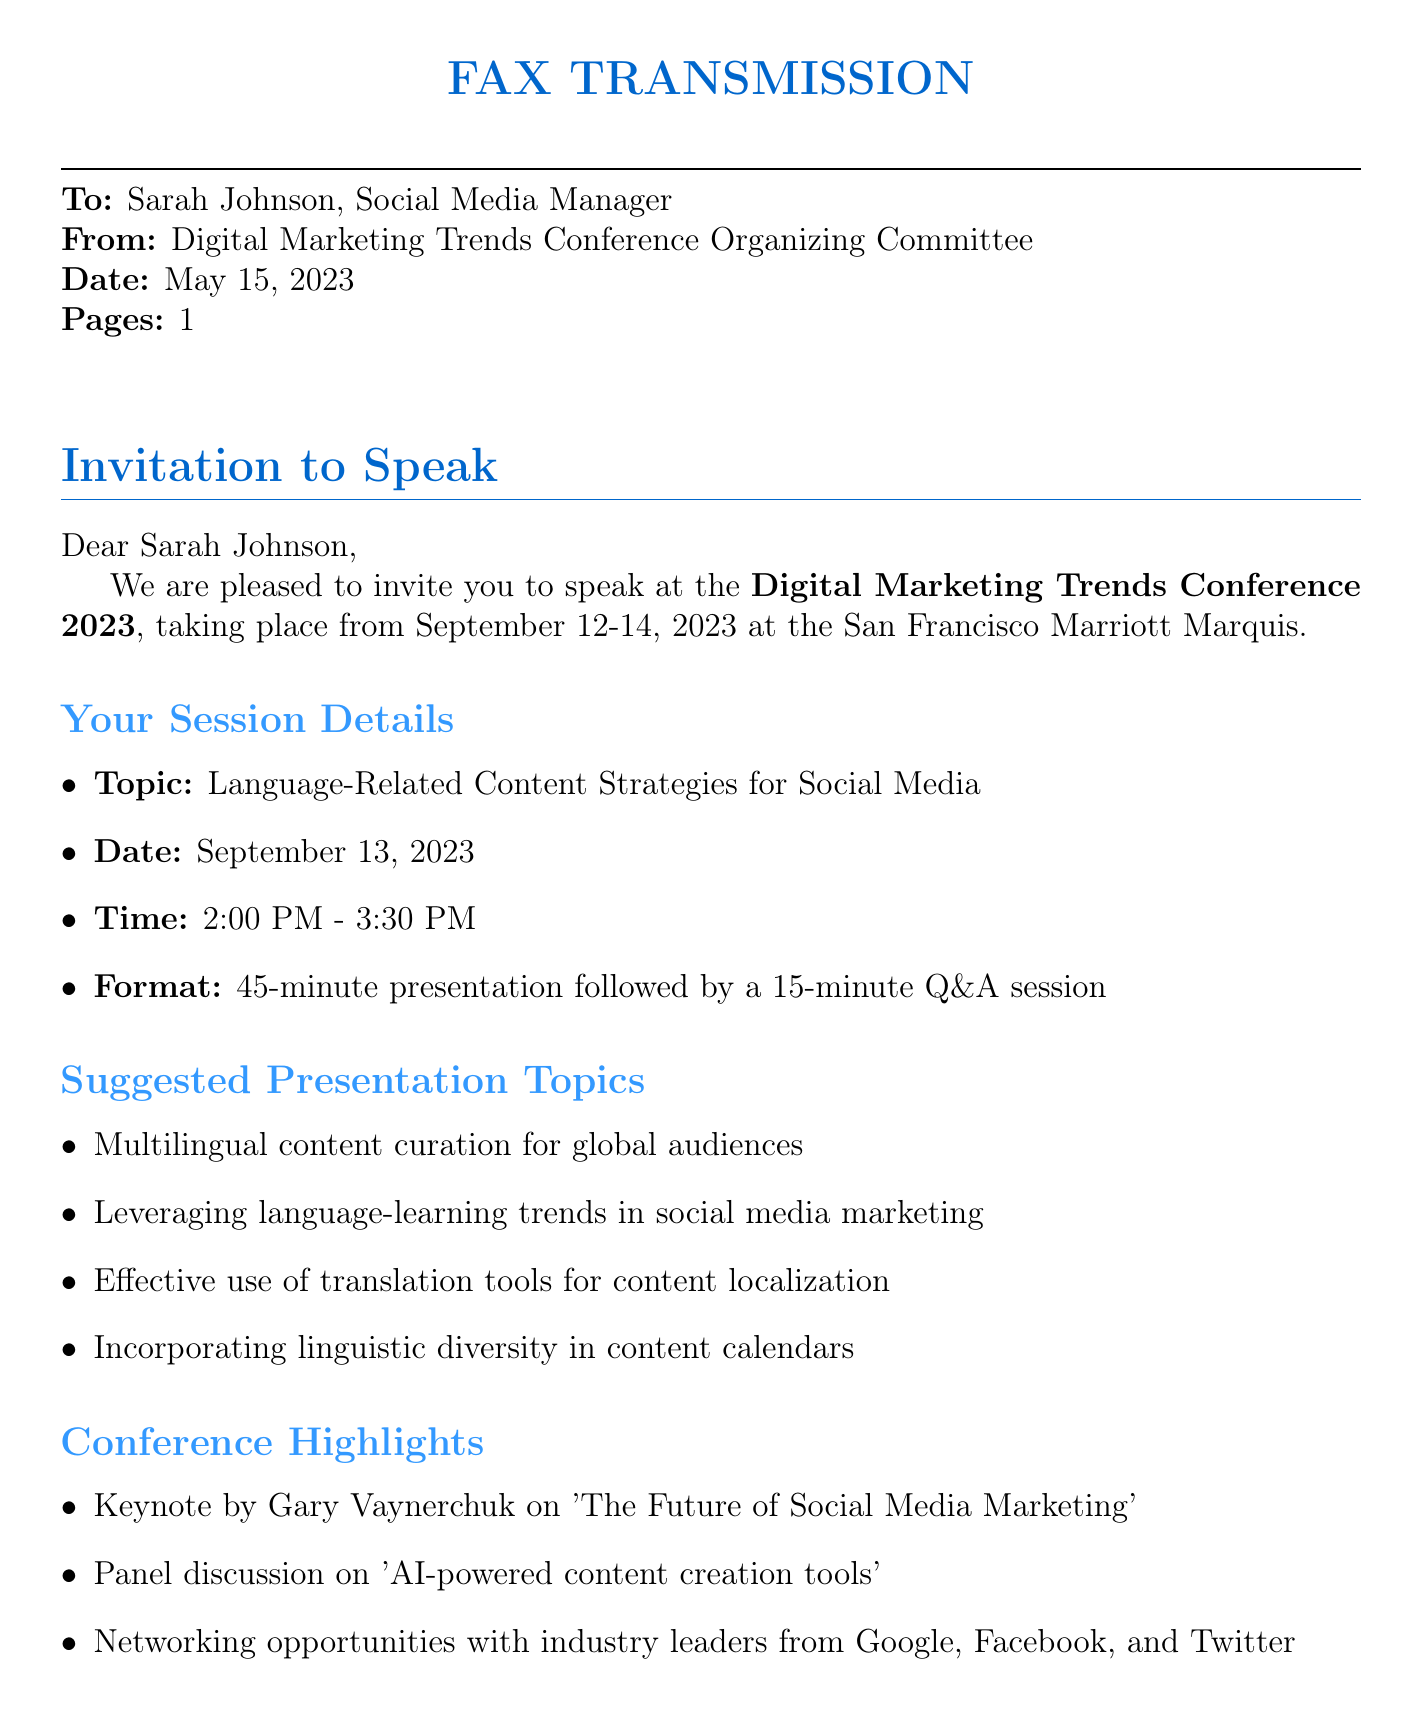What is the name of the conference? The name of the conference is explicitly stated in the document.
Answer: Digital Marketing Trends Conference 2023 What are the dates of the conference? The document mentions the specific dates for the conference.
Answer: September 12-14, 2023 Who is the keynote speaker? The document references the keynote speaker for the conference.
Answer: Gary Vaynerchuk What is the time of Sarah Johnson's session? The time of the session for Sarah Johnson is given in the document.
Answer: 2:00 PM - 3:30 PM How much is the reimbursement for travel and accommodation? The document specifies the maximum amount for travel and accommodation reimbursement.
Answer: $1,000 What is one of the suggested presentation topics? The document lists several suggested topics for the presentation.
Answer: Multilingual content curation for global audiences What is the format of the session? The document details the structure of the session to be presented.
Answer: 45-minute presentation followed by a 15-minute Q&A session When should Sarah confirm her participation? The document provides a deadline for confirming participation.
Answer: June 15, 2023 How many attendees are expected at the conference? The number of expected attendees is mentioned in the document.
Answer: Over 5,000 attendees 